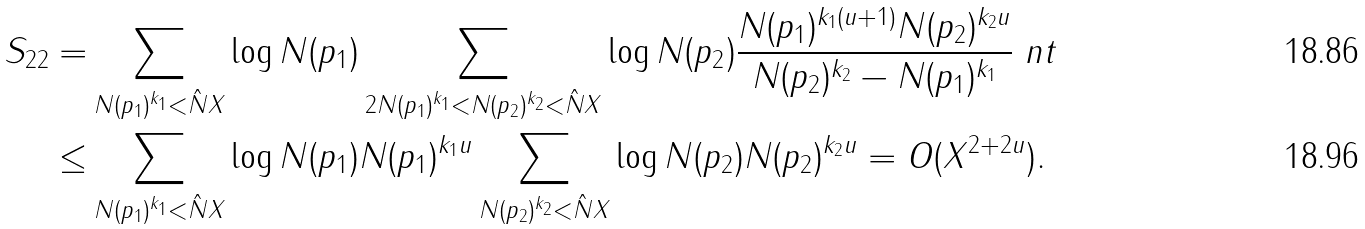<formula> <loc_0><loc_0><loc_500><loc_500>S _ { 2 2 } = & \sum _ { N ( p _ { 1 } ) ^ { k _ { 1 } } < \hat { N } X } \log { N ( p _ { 1 } ) } \sum _ { 2 N ( p _ { 1 } ) ^ { k _ { 1 } } < N ( p _ { 2 } ) ^ { k _ { 2 } } < \hat { N } X } \log { N ( p _ { 2 } ) } \frac { N ( p _ { 1 } ) ^ { k _ { 1 } ( u + 1 ) } N ( p _ { 2 } ) ^ { k _ { 2 } u } } { N ( p _ { 2 } ) ^ { k _ { 2 } } - N ( p _ { 1 } ) ^ { k _ { 1 } } } \ n t \\ \leq & \sum _ { N ( p _ { 1 } ) ^ { k _ { 1 } } < \hat { N } X } \log { N ( p _ { 1 } ) } N ( p _ { 1 } ) ^ { k _ { 1 } u } \sum _ { N ( p _ { 2 } ) ^ { k _ { 2 } } < \hat { N } X } \log { N ( p _ { 2 } ) } N ( p _ { 2 } ) ^ { k _ { 2 } u } = O ( X ^ { 2 + 2 u } ) .</formula> 